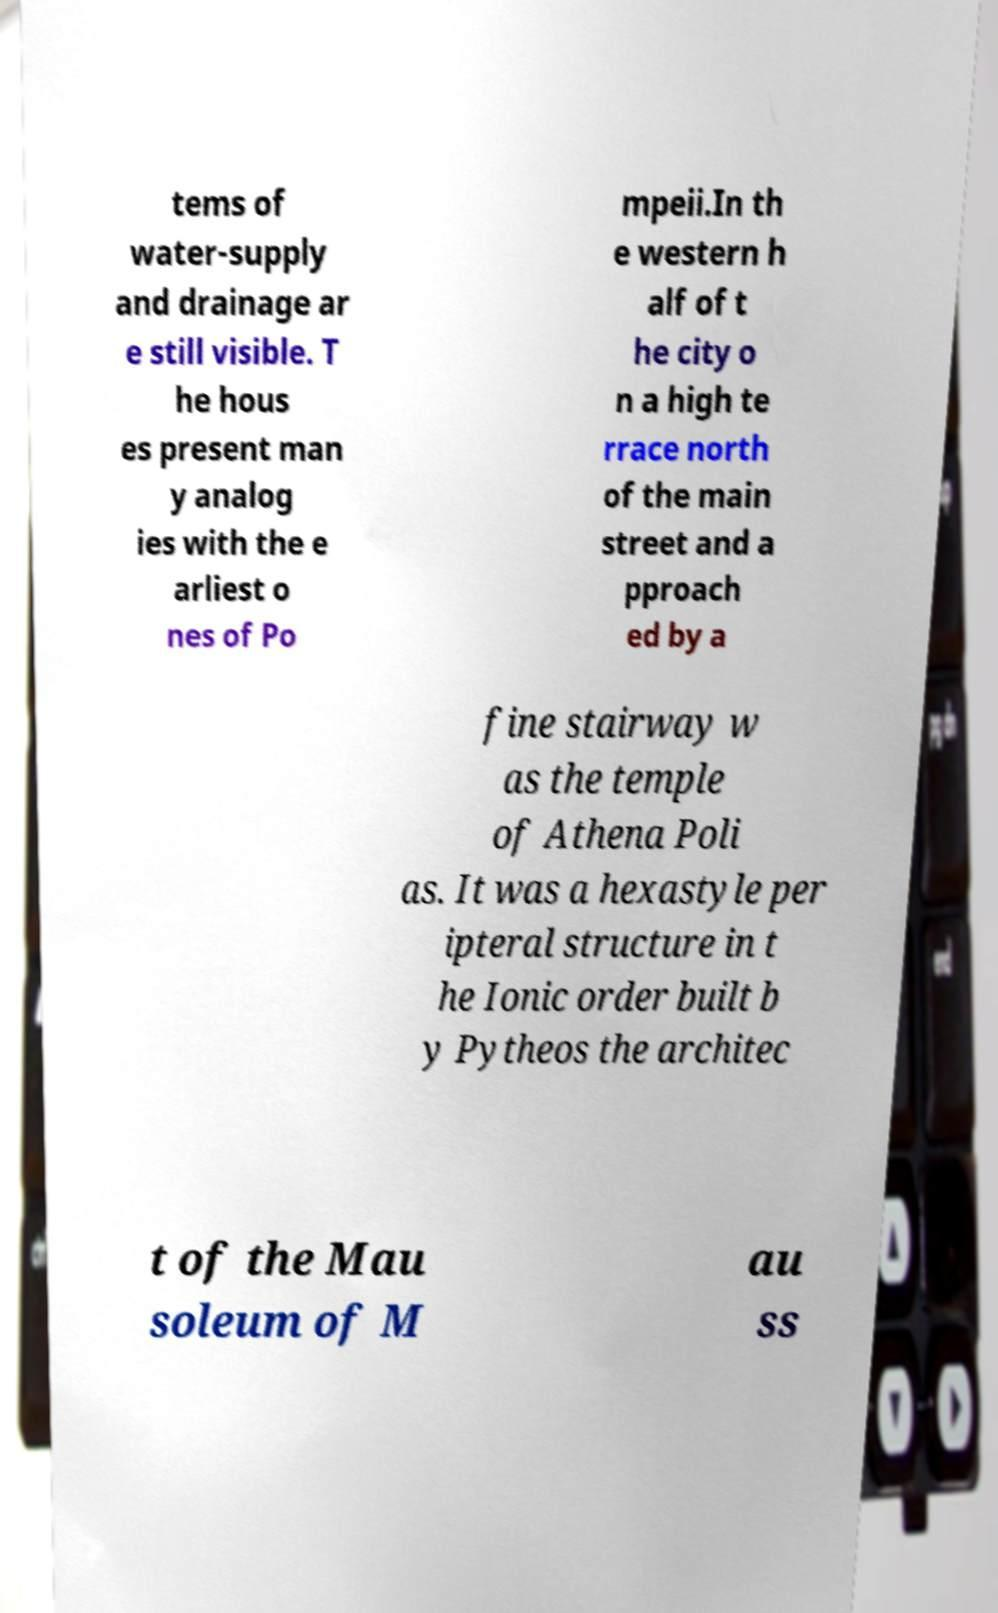Please identify and transcribe the text found in this image. tems of water-supply and drainage ar e still visible. T he hous es present man y analog ies with the e arliest o nes of Po mpeii.In th e western h alf of t he city o n a high te rrace north of the main street and a pproach ed by a fine stairway w as the temple of Athena Poli as. It was a hexastyle per ipteral structure in t he Ionic order built b y Pytheos the architec t of the Mau soleum of M au ss 